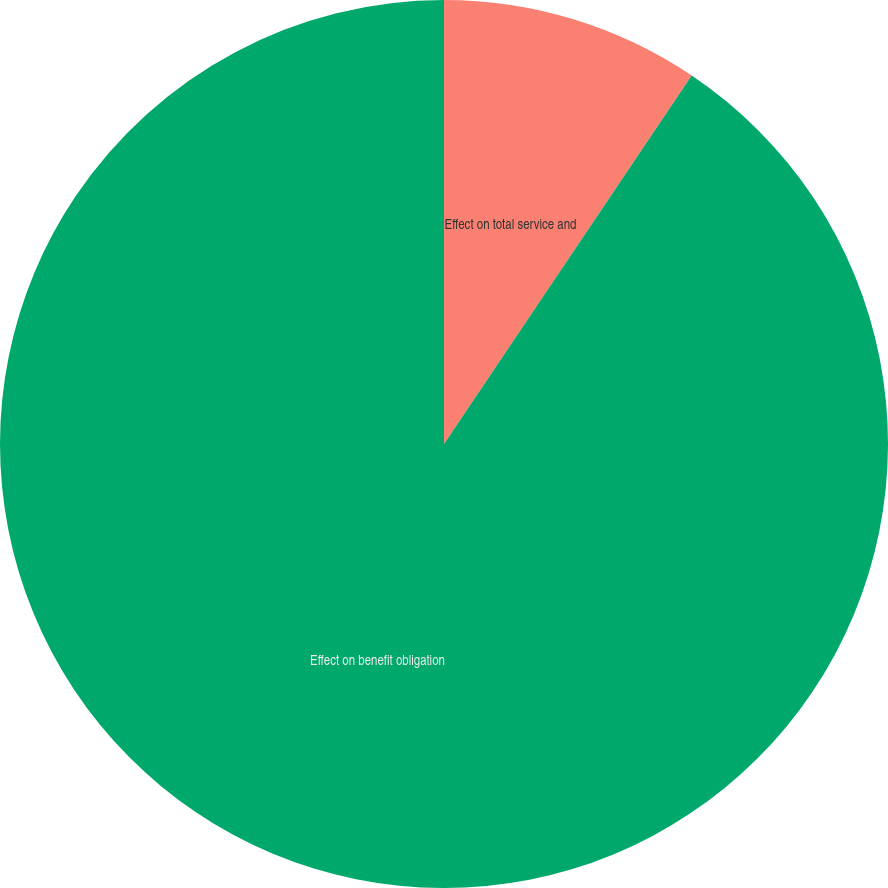Convert chart. <chart><loc_0><loc_0><loc_500><loc_500><pie_chart><fcel>Effect on total service and<fcel>Effect on benefit obligation<nl><fcel>9.42%<fcel>90.58%<nl></chart> 